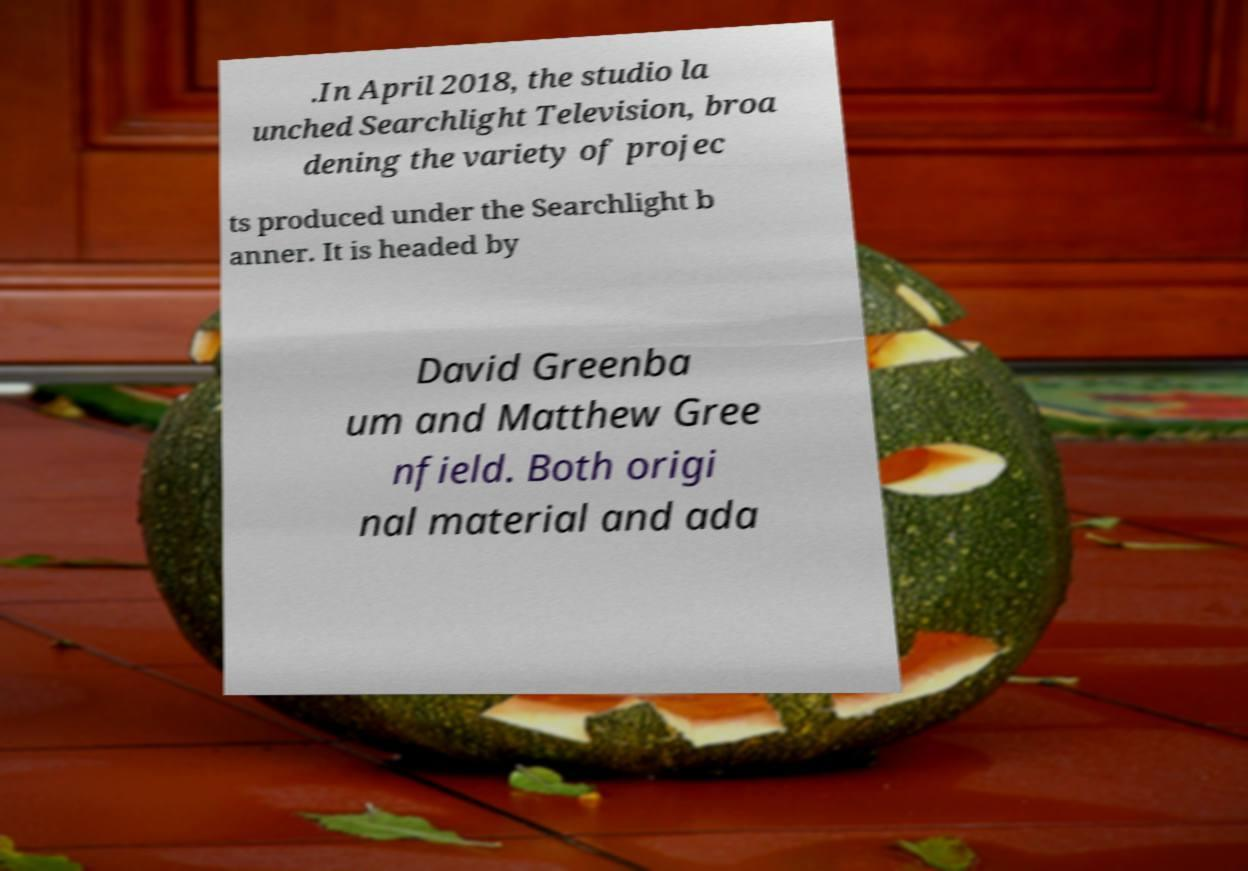I need the written content from this picture converted into text. Can you do that? .In April 2018, the studio la unched Searchlight Television, broa dening the variety of projec ts produced under the Searchlight b anner. It is headed by David Greenba um and Matthew Gree nfield. Both origi nal material and ada 